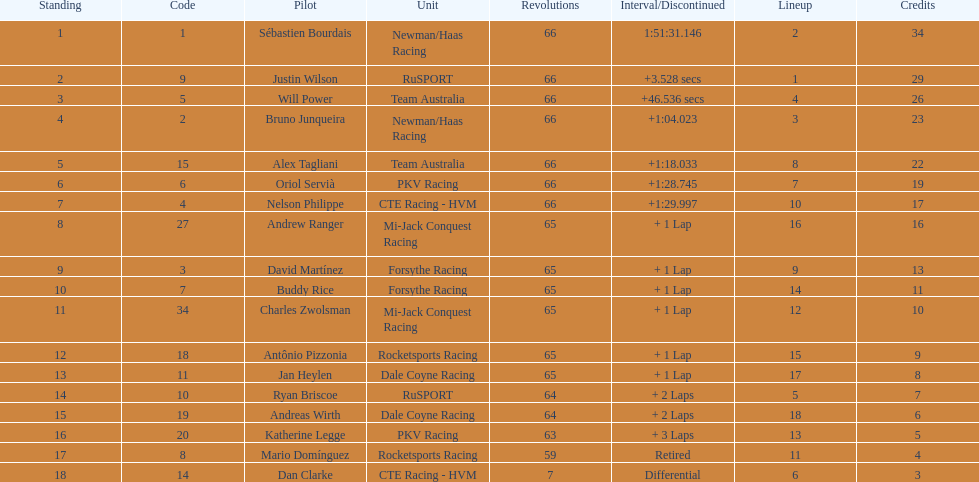In which nation are the highest number of drivers represented? United Kingdom. 